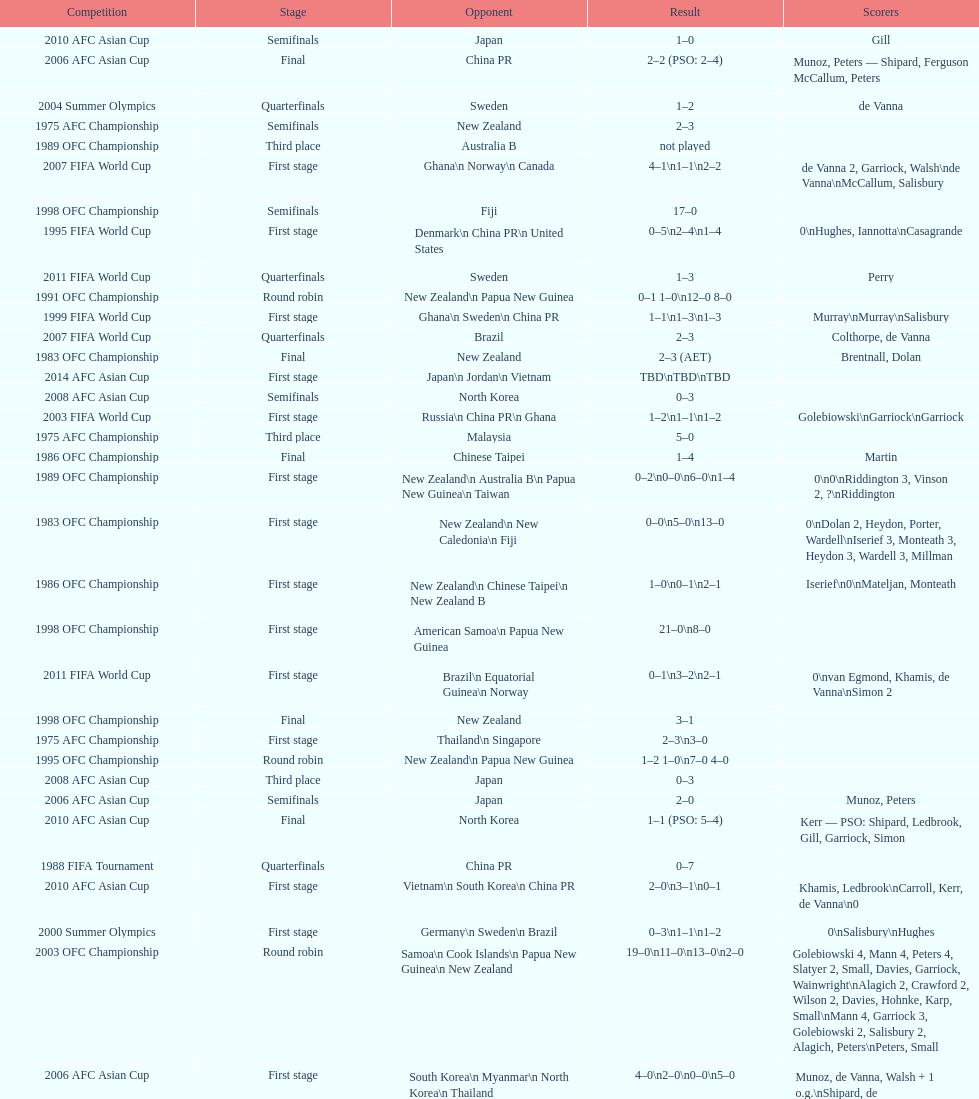How many points were scored in the final round of the 2012 summer olympics afc qualification? 12. Can you parse all the data within this table? {'header': ['Competition', 'Stage', 'Opponent', 'Result', 'Scorers'], 'rows': [['2010 AFC Asian Cup', 'Semifinals', 'Japan', '1–0', 'Gill'], ['2006 AFC Asian Cup', 'Final', 'China PR', '2–2 (PSO: 2–4)', 'Munoz, Peters — Shipard, Ferguson McCallum, Peters'], ['2004 Summer Olympics', 'Quarterfinals', 'Sweden', '1–2', 'de Vanna'], ['1975 AFC Championship', 'Semifinals', 'New Zealand', '2–3', ''], ['1989 OFC Championship', 'Third place', 'Australia B', 'not played', ''], ['2007 FIFA World Cup', 'First stage', 'Ghana\\n\xa0Norway\\n\xa0Canada', '4–1\\n1–1\\n2–2', 'de Vanna 2, Garriock, Walsh\\nde Vanna\\nMcCallum, Salisbury'], ['1998 OFC Championship', 'Semifinals', 'Fiji', '17–0', ''], ['1995 FIFA World Cup', 'First stage', 'Denmark\\n\xa0China PR\\n\xa0United States', '0–5\\n2–4\\n1–4', '0\\nHughes, Iannotta\\nCasagrande'], ['2011 FIFA World Cup', 'Quarterfinals', 'Sweden', '1–3', 'Perry'], ['1991 OFC Championship', 'Round robin', 'New Zealand\\n\xa0Papua New Guinea', '0–1 1–0\\n12–0 8–0', ''], ['1999 FIFA World Cup', 'First stage', 'Ghana\\n\xa0Sweden\\n\xa0China PR', '1–1\\n1–3\\n1–3', 'Murray\\nMurray\\nSalisbury'], ['2007 FIFA World Cup', 'Quarterfinals', 'Brazil', '2–3', 'Colthorpe, de Vanna'], ['1983 OFC Championship', 'Final', 'New Zealand', '2–3 (AET)', 'Brentnall, Dolan'], ['2014 AFC Asian Cup', 'First stage', 'Japan\\n\xa0Jordan\\n\xa0Vietnam', 'TBD\\nTBD\\nTBD', ''], ['2008 AFC Asian Cup', 'Semifinals', 'North Korea', '0–3', ''], ['2003 FIFA World Cup', 'First stage', 'Russia\\n\xa0China PR\\n\xa0Ghana', '1–2\\n1–1\\n1–2', 'Golebiowski\\nGarriock\\nGarriock'], ['1975 AFC Championship', 'Third place', 'Malaysia', '5–0', ''], ['1986 OFC Championship', 'Final', 'Chinese Taipei', '1–4', 'Martin'], ['1989 OFC Championship', 'First stage', 'New Zealand\\n Australia B\\n\xa0Papua New Guinea\\n\xa0Taiwan', '0–2\\n0–0\\n6–0\\n1–4', '0\\n0\\nRiddington 3, Vinson 2,\xa0?\\nRiddington'], ['1983 OFC Championship', 'First stage', 'New Zealand\\n\xa0New Caledonia\\n\xa0Fiji', '0–0\\n5–0\\n13–0', '0\\nDolan 2, Heydon, Porter, Wardell\\nIserief 3, Monteath 3, Heydon 3, Wardell 3, Millman'], ['1986 OFC Championship', 'First stage', 'New Zealand\\n\xa0Chinese Taipei\\n New Zealand B', '1–0\\n0–1\\n2–1', 'Iserief\\n0\\nMateljan, Monteath'], ['1998 OFC Championship', 'First stage', 'American Samoa\\n\xa0Papua New Guinea', '21–0\\n8–0', ''], ['2011 FIFA World Cup', 'First stage', 'Brazil\\n\xa0Equatorial Guinea\\n\xa0Norway', '0–1\\n3–2\\n2–1', '0\\nvan Egmond, Khamis, de Vanna\\nSimon 2'], ['1998 OFC Championship', 'Final', 'New Zealand', '3–1', ''], ['1975 AFC Championship', 'First stage', 'Thailand\\n\xa0Singapore', '2–3\\n3–0', ''], ['1995 OFC Championship', 'Round robin', 'New Zealand\\n\xa0Papua New Guinea', '1–2 1–0\\n7–0 4–0', ''], ['2008 AFC Asian Cup', 'Third place', 'Japan', '0–3', ''], ['2006 AFC Asian Cup', 'Semifinals', 'Japan', '2–0', 'Munoz, Peters'], ['2010 AFC Asian Cup', 'Final', 'North Korea', '1–1 (PSO: 5–4)', 'Kerr — PSO: Shipard, Ledbrook, Gill, Garriock, Simon'], ['1988 FIFA Tournament', 'Quarterfinals', 'China PR', '0–7', ''], ['2010 AFC Asian Cup', 'First stage', 'Vietnam\\n\xa0South Korea\\n\xa0China PR', '2–0\\n3–1\\n0–1', 'Khamis, Ledbrook\\nCarroll, Kerr, de Vanna\\n0'], ['2000 Summer Olympics', 'First stage', 'Germany\\n\xa0Sweden\\n\xa0Brazil', '0–3\\n1–1\\n1–2', '0\\nSalisbury\\nHughes'], ['2003 OFC Championship', 'Round robin', 'Samoa\\n\xa0Cook Islands\\n\xa0Papua New Guinea\\n\xa0New Zealand', '19–0\\n11–0\\n13–0\\n2–0', 'Golebiowski 4, Mann 4, Peters 4, Slatyer 2, Small, Davies, Garriock, Wainwright\\nAlagich 2, Crawford 2, Wilson 2, Davies, Hohnke, Karp, Small\\nMann 4, Garriock 3, Golebiowski 2, Salisbury 2, Alagich, Peters\\nPeters, Small'], ['2006 AFC Asian Cup', 'First stage', 'South Korea\\n\xa0Myanmar\\n\xa0North Korea\\n\xa0Thailand', '4–0\\n2–0\\n0–0\\n5–0', 'Munoz, de Vanna, Walsh + 1 o.g.\\nShipard, de Vanna\\n0\\nBurgess, Ferguson, Gill, de Vanna, Walsh'], ['2008 AFC Asian Cup', 'First stage', 'Chinese Taipei\\n\xa0South Korea\\n\xa0Japan', '4–0\\n2–0', 'Garriock 2, Tristram, de Vanna\\nPerry, de Vanna\\nPolkinghorne'], ['2004 Summer Olympics', 'First stage', 'Brazil\\n\xa0Greece\\n\xa0United States', '0–1\\n1–0\\n1–1', '0\\nGarriock\\nPeters'], ['2012 Summer Olympics\\nAFC qualification', 'Final round', 'North Korea\\n\xa0Thailand\\n\xa0Japan\\n\xa0China PR\\n\xa0South Korea', '0–1\\n5–1\\n0–1\\n1–0\\n2–1', '0\\nHeyman 2, Butt, van Egmond, Simon\\n0\\nvan Egmond\\nButt, de Vanna'], ['1988 FIFA Tournament', 'First stage', 'Brazil\\n\xa0Thailand\\n\xa0Norway', '1–0\\n3–0\\n0–3', '']]} 